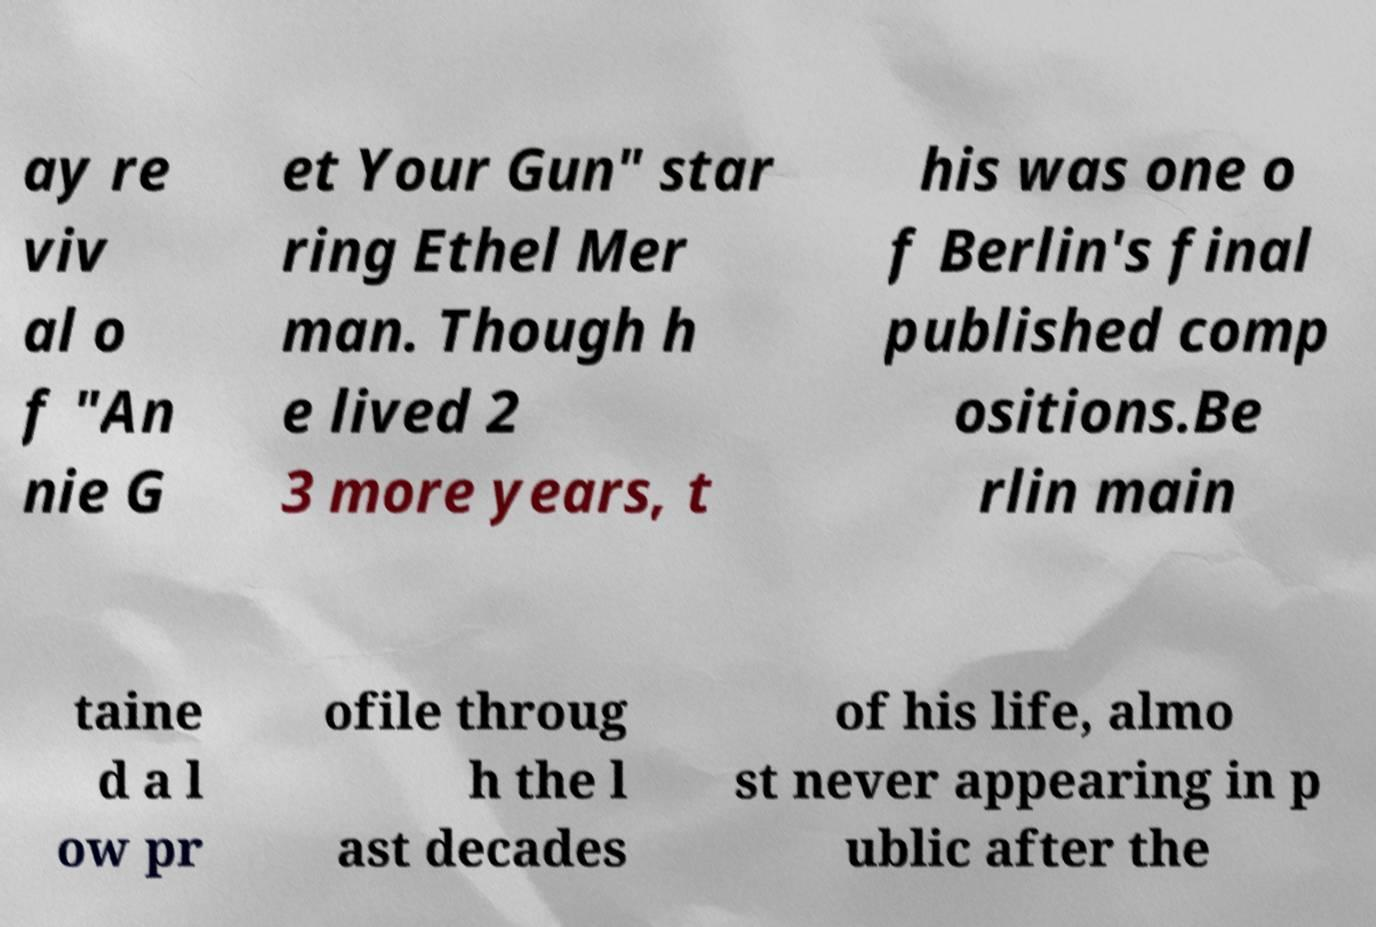Can you read and provide the text displayed in the image?This photo seems to have some interesting text. Can you extract and type it out for me? ay re viv al o f "An nie G et Your Gun" star ring Ethel Mer man. Though h e lived 2 3 more years, t his was one o f Berlin's final published comp ositions.Be rlin main taine d a l ow pr ofile throug h the l ast decades of his life, almo st never appearing in p ublic after the 